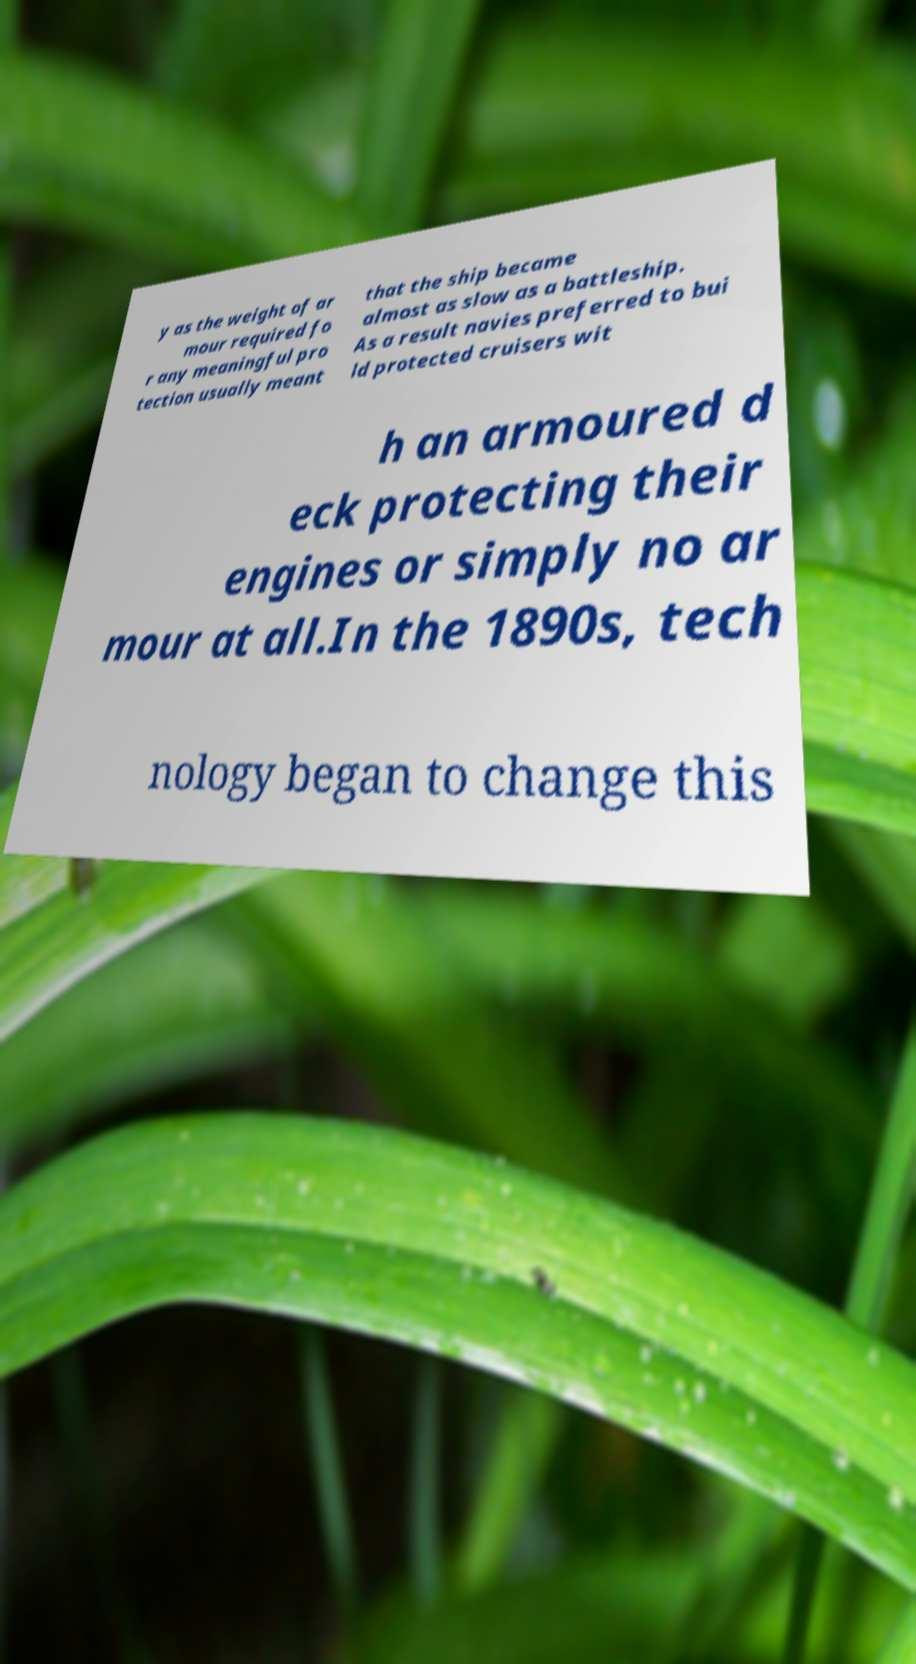For documentation purposes, I need the text within this image transcribed. Could you provide that? y as the weight of ar mour required fo r any meaningful pro tection usually meant that the ship became almost as slow as a battleship. As a result navies preferred to bui ld protected cruisers wit h an armoured d eck protecting their engines or simply no ar mour at all.In the 1890s, tech nology began to change this 